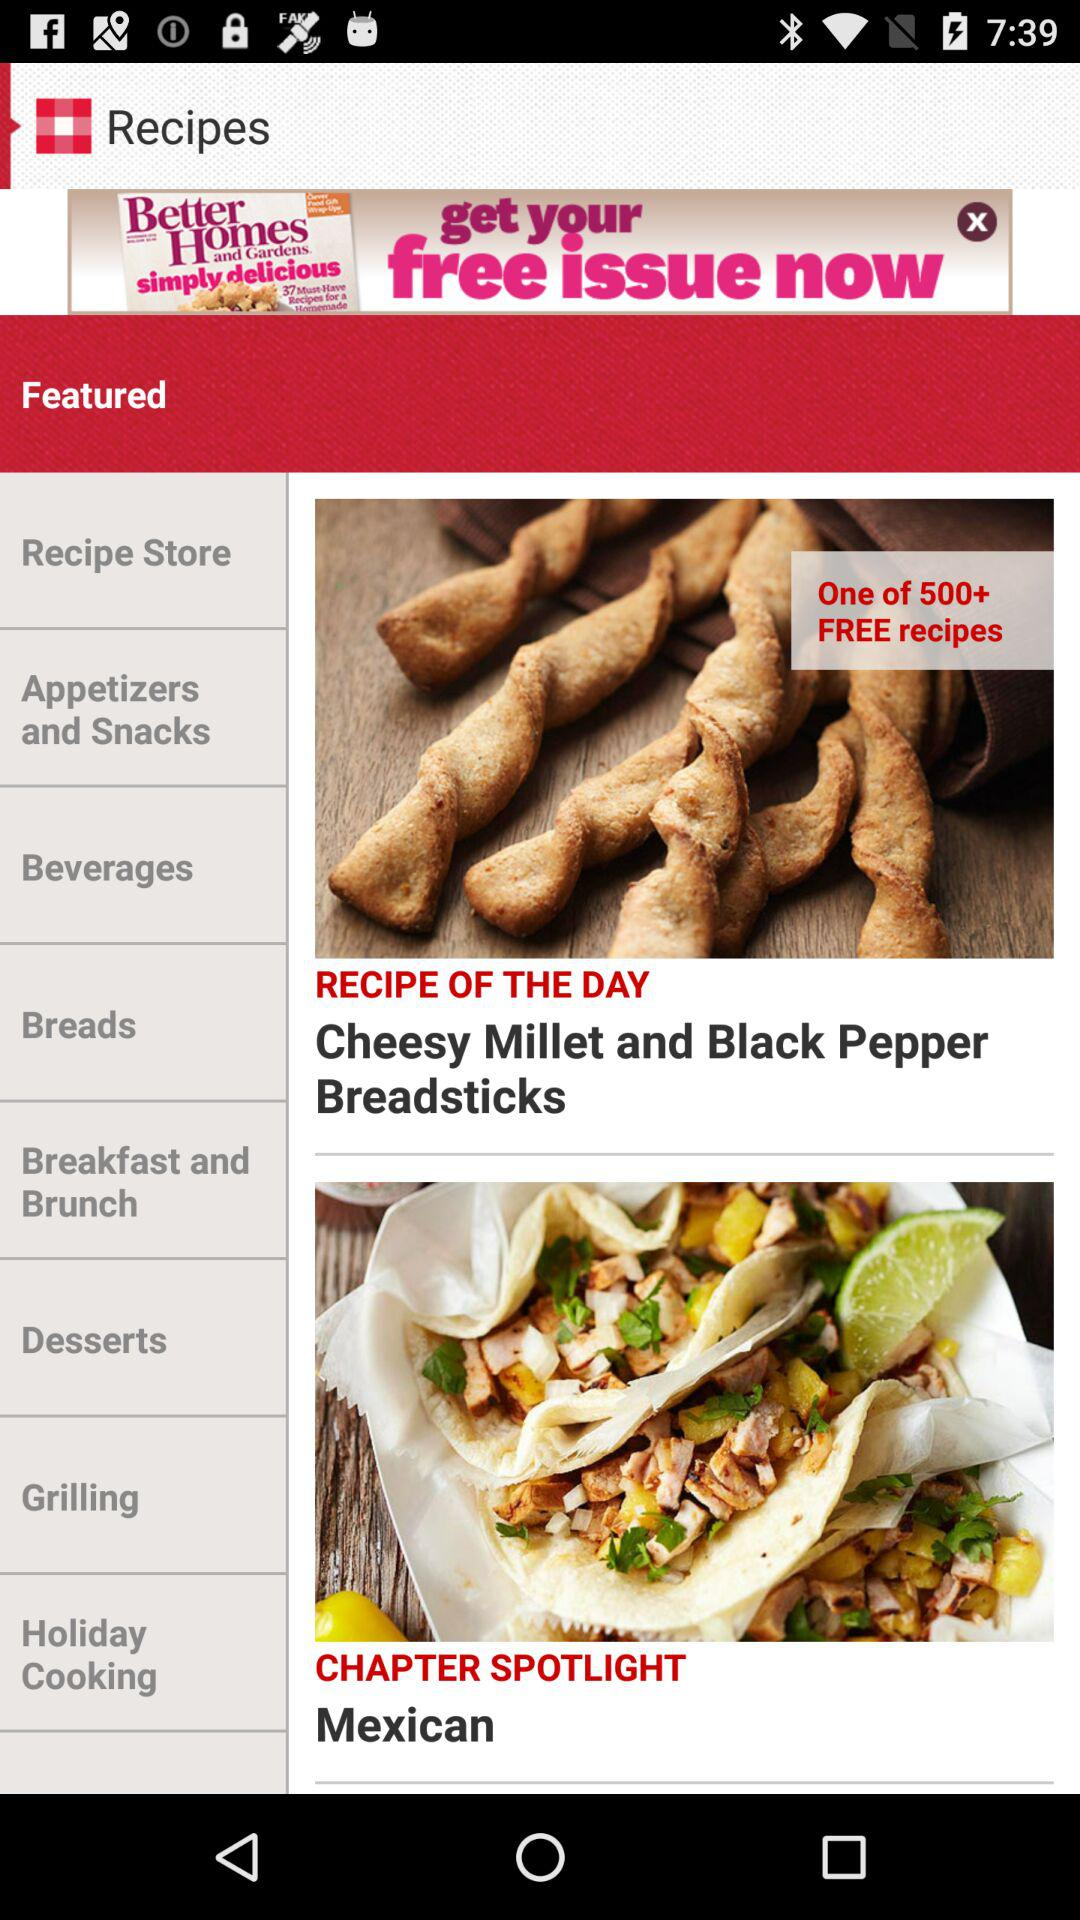How many free recipes are there? There are "500+" free recipes. 